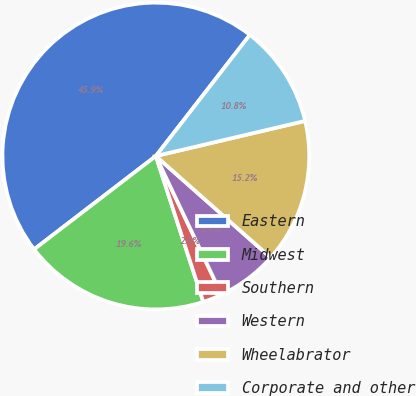Convert chart. <chart><loc_0><loc_0><loc_500><loc_500><pie_chart><fcel>Eastern<fcel>Midwest<fcel>Southern<fcel>Western<fcel>Wheelabrator<fcel>Corporate and other<nl><fcel>45.91%<fcel>19.59%<fcel>2.04%<fcel>6.43%<fcel>15.2%<fcel>10.82%<nl></chart> 